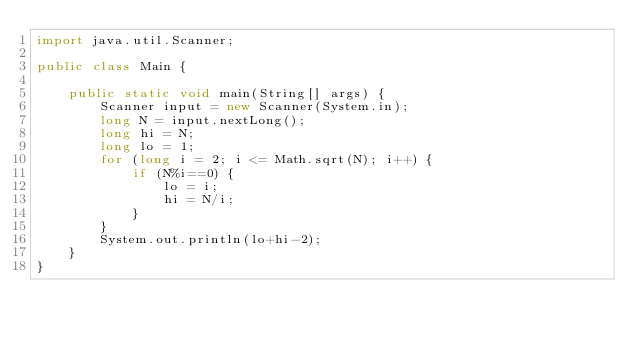<code> <loc_0><loc_0><loc_500><loc_500><_Java_>import java.util.Scanner;

public class Main {

	public static void main(String[] args) {
		Scanner input = new Scanner(System.in);
		long N = input.nextLong();
		long hi = N;
		long lo = 1;
		for (long i = 2; i <= Math.sqrt(N); i++) {
			if (N%i==0) {
				lo = i;
				hi = N/i;
			}
		}
		System.out.println(lo+hi-2);
	}
}</code> 